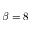<formula> <loc_0><loc_0><loc_500><loc_500>\beta = 8</formula> 